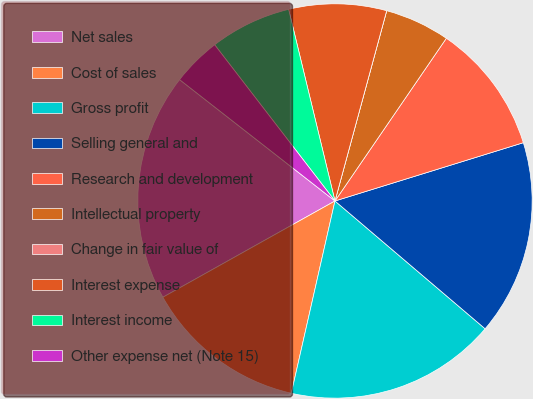Convert chart. <chart><loc_0><loc_0><loc_500><loc_500><pie_chart><fcel>Net sales<fcel>Cost of sales<fcel>Gross profit<fcel>Selling general and<fcel>Research and development<fcel>Intellectual property<fcel>Change in fair value of<fcel>Interest expense<fcel>Interest income<fcel>Other expense net (Note 15)<nl><fcel>18.67%<fcel>13.33%<fcel>17.33%<fcel>16.0%<fcel>10.67%<fcel>5.33%<fcel>0.0%<fcel>8.0%<fcel>6.67%<fcel>4.0%<nl></chart> 